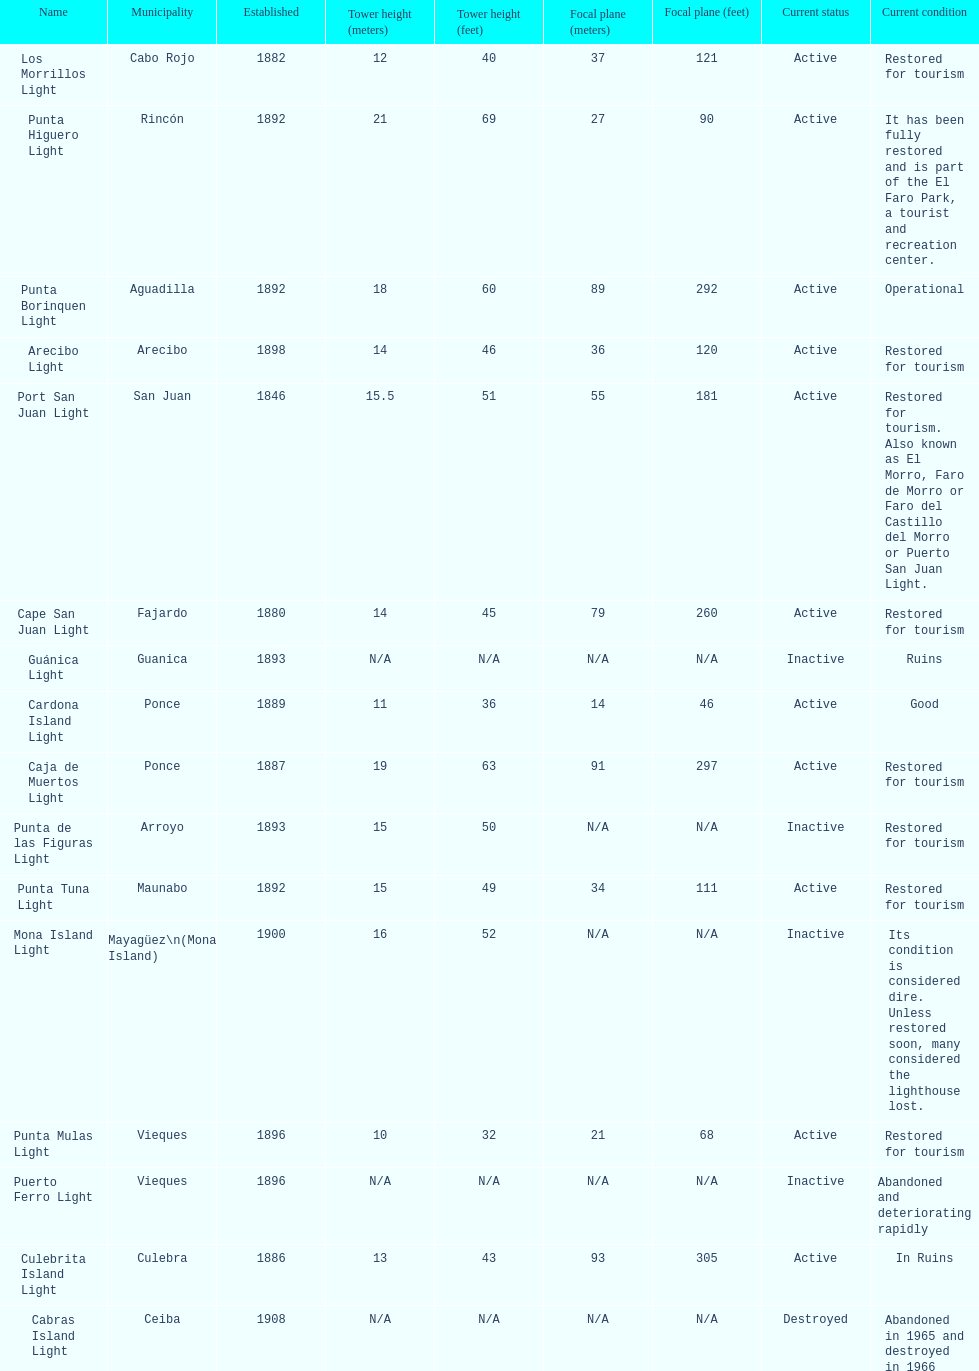How many establishments are restored for tourism? 9. 